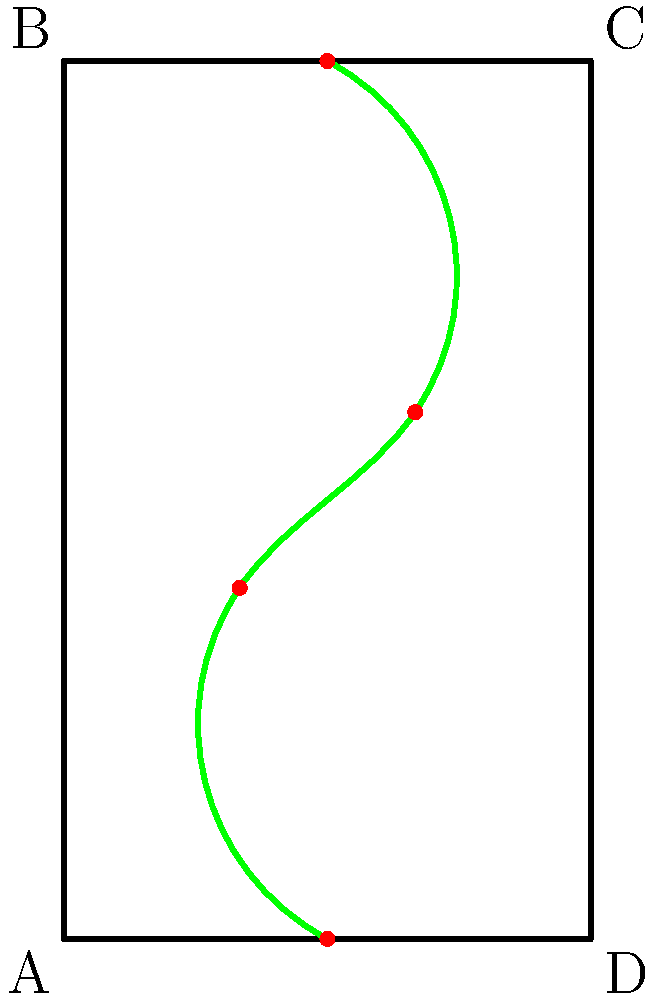Based on the growth pattern of the climbing plant shown on the trellis, which point would the plant likely reach next if it continues its current growth trajectory? To determine the next likely point the climbing plant will reach, we need to analyze its current growth pattern:

1. The plant starts at the bottom center of the trellis (point $(1.5, 0)$).
2. It then grows towards the left, reaching point $(1, 2)$.
3. The next growth point is towards the right, at $(2, 3)$.
4. Finally, it reaches the top center at $(1.5, 5)$.

Observing this pattern, we can deduce:
- The plant alternates between left and right as it grows upward.
- It maintains a generally vertical trajectory.
- The horizontal distance between points decreases as it reaches the top.

Given this pattern, the next likely point would be slightly to the left of the top center, approximately at $(1.25, 5.5)$ if the trellis were extended upward.

However, since the trellis ends at $y=5$, the plant is most likely to continue growing along the top edge of the trellis, reaching point C $(3, 5)$ next.
Answer: C $(3, 5)$ 